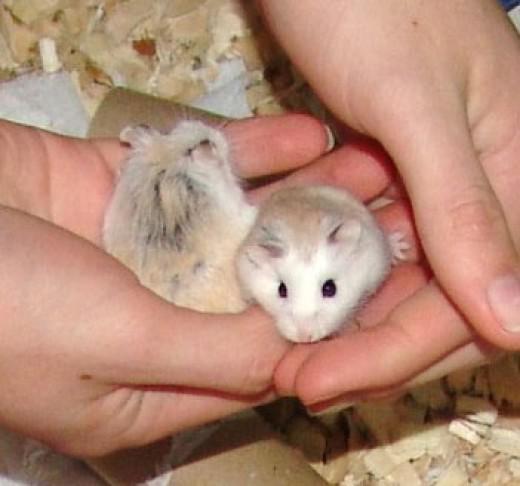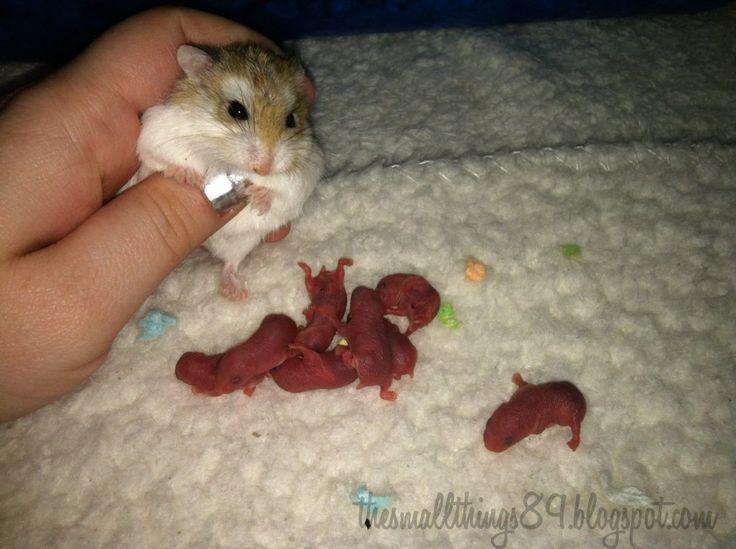The first image is the image on the left, the second image is the image on the right. Examine the images to the left and right. Is the description "An image shows one adult rodent with more than one newborn nearby." accurate? Answer yes or no. Yes. The first image is the image on the left, the second image is the image on the right. Analyze the images presented: Is the assertion "There are at least two newborn rodents." valid? Answer yes or no. Yes. 